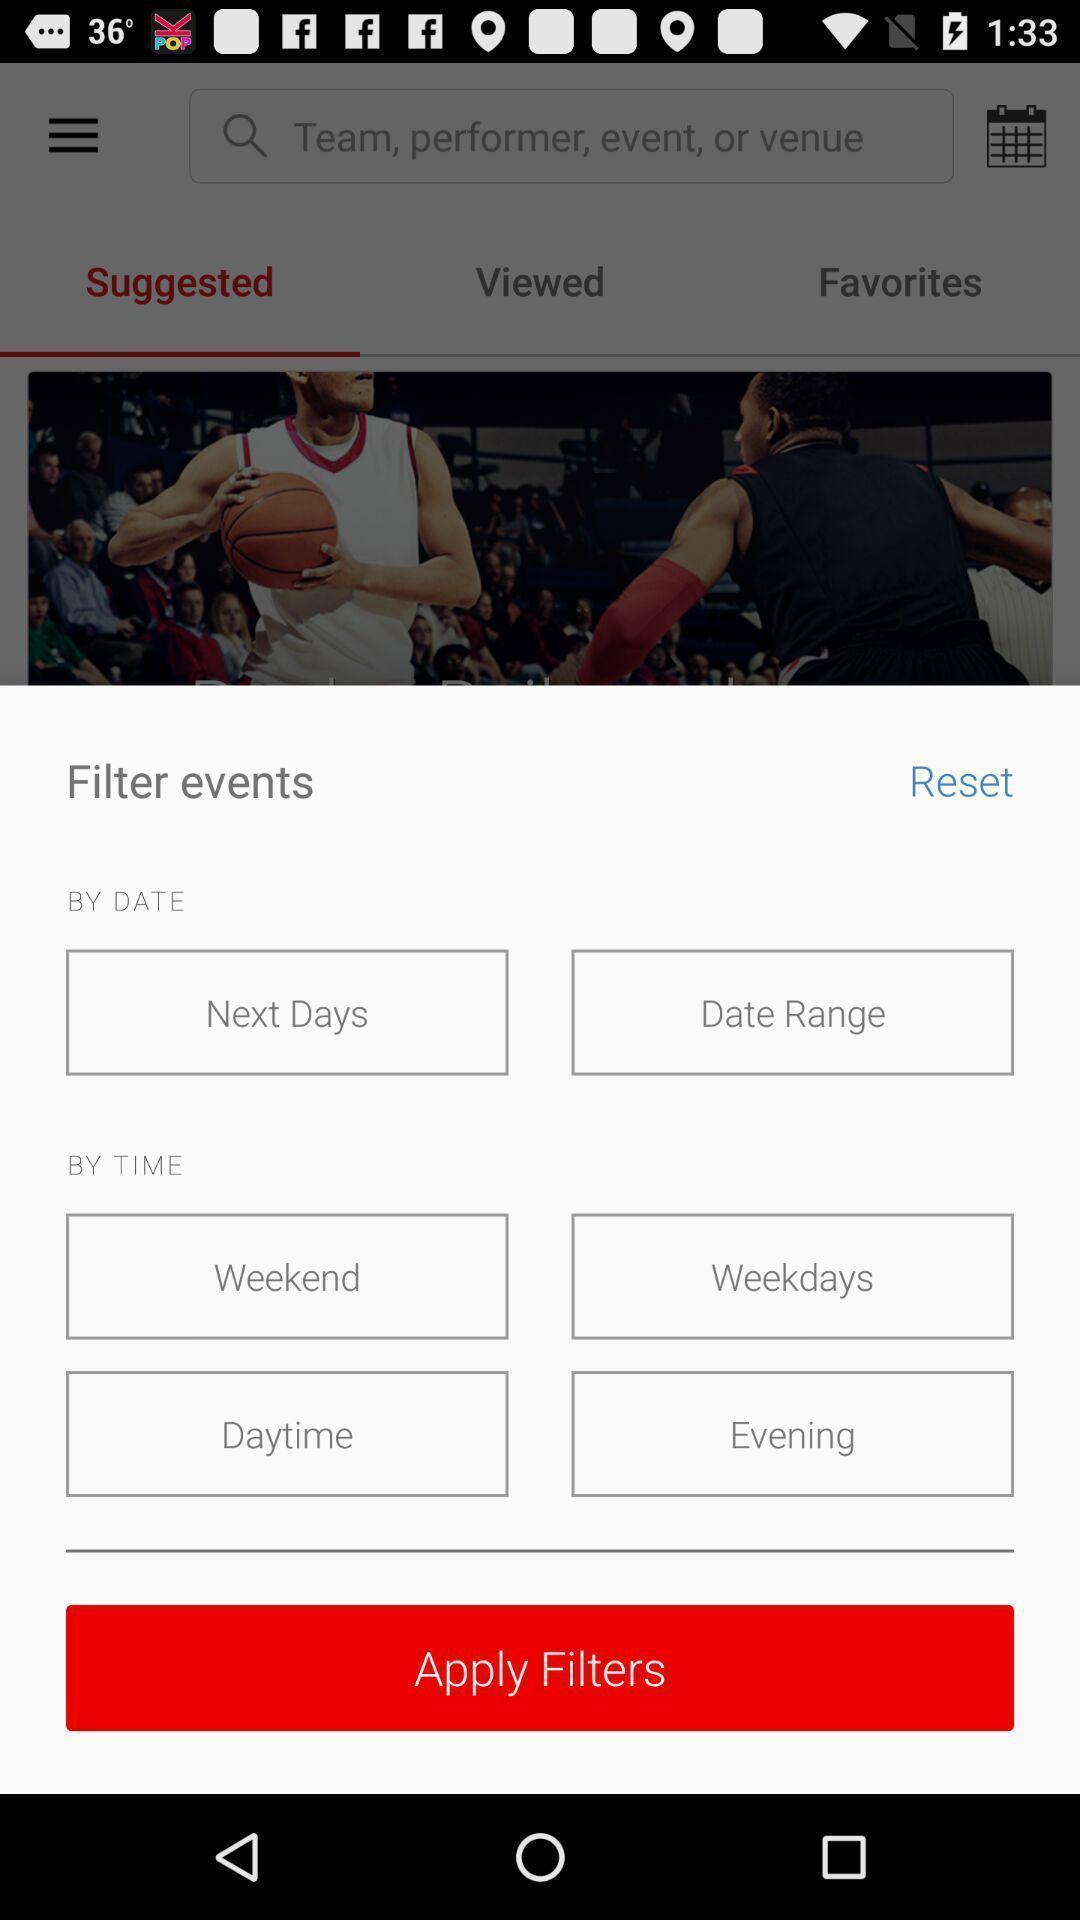Describe this image in words. Widget displaying options to apply a filter. 